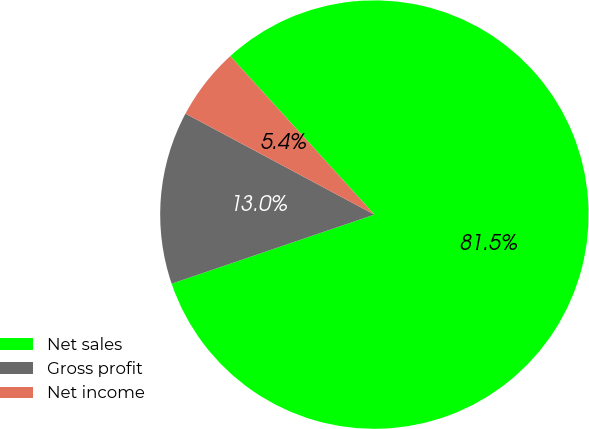Convert chart to OTSL. <chart><loc_0><loc_0><loc_500><loc_500><pie_chart><fcel>Net sales<fcel>Gross profit<fcel>Net income<nl><fcel>81.52%<fcel>13.04%<fcel>5.44%<nl></chart> 